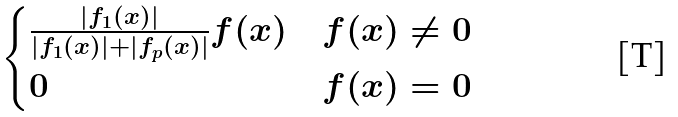<formula> <loc_0><loc_0><loc_500><loc_500>\begin{cases} \frac { | f _ { 1 } ( x ) | } { | f _ { 1 } ( x ) | + | f _ { p } ( x ) | } f ( x ) & f ( x ) \neq 0 \\ 0 & f ( x ) = 0 \end{cases}</formula> 